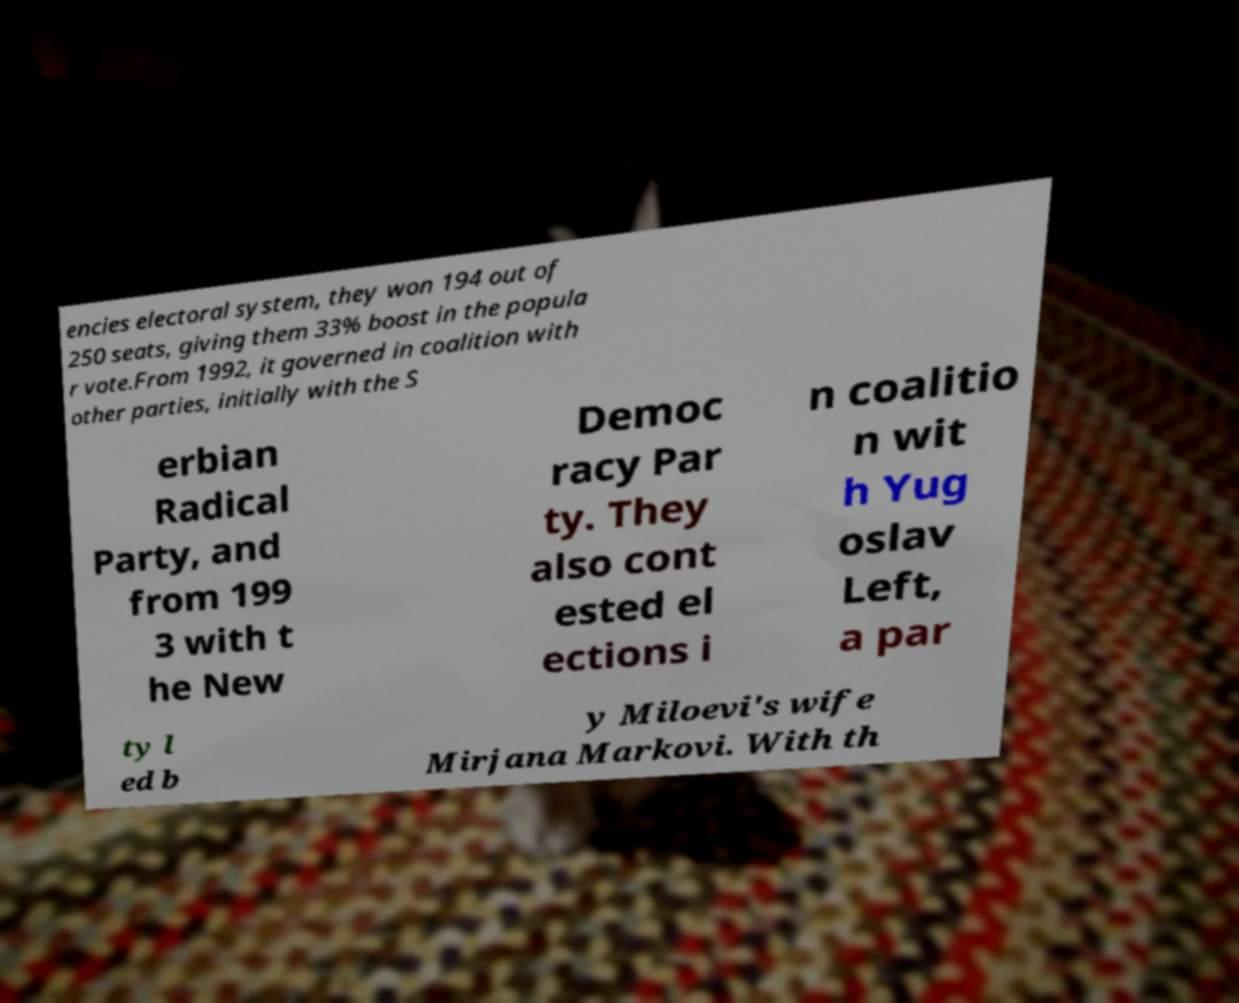There's text embedded in this image that I need extracted. Can you transcribe it verbatim? encies electoral system, they won 194 out of 250 seats, giving them 33% boost in the popula r vote.From 1992, it governed in coalition with other parties, initially with the S erbian Radical Party, and from 199 3 with t he New Democ racy Par ty. They also cont ested el ections i n coalitio n wit h Yug oslav Left, a par ty l ed b y Miloevi's wife Mirjana Markovi. With th 